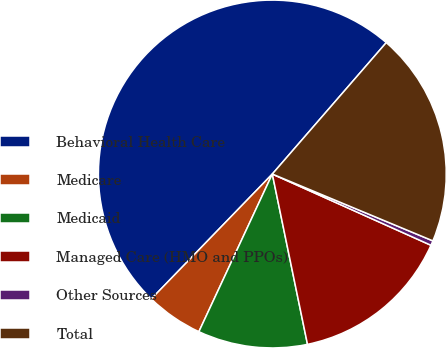Convert chart. <chart><loc_0><loc_0><loc_500><loc_500><pie_chart><fcel>Behavioral Health Care<fcel>Medicare<fcel>Medicaid<fcel>Managed Care (HMO and PPOs)<fcel>Other Sources<fcel>Total<nl><fcel>49.12%<fcel>5.31%<fcel>10.18%<fcel>15.04%<fcel>0.44%<fcel>19.91%<nl></chart> 